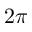<formula> <loc_0><loc_0><loc_500><loc_500>2 \pi</formula> 